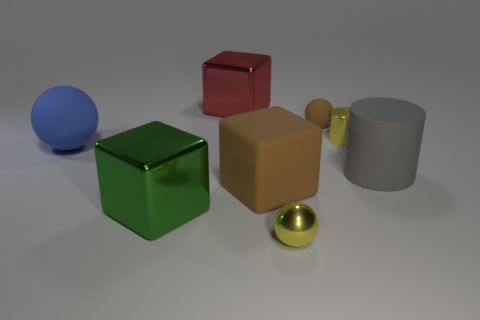The metallic sphere is what size?
Make the answer very short. Small. What number of matte things are the same size as the green block?
Make the answer very short. 3. Do the matte thing on the left side of the big green shiny thing and the metal cube that is in front of the small brown thing have the same size?
Ensure brevity in your answer.  Yes. The big object that is behind the blue matte sphere has what shape?
Ensure brevity in your answer.  Cube. What is the yellow object in front of the small thing that is to the right of the small rubber ball made of?
Make the answer very short. Metal. Is there a rubber thing that has the same color as the tiny matte sphere?
Your answer should be compact. Yes. There is a blue rubber object; is its size the same as the brown thing on the left side of the yellow metal sphere?
Make the answer very short. Yes. There is a small shiny thing behind the yellow object in front of the big blue rubber ball; what number of small rubber balls are to the left of it?
Make the answer very short. 1. How many red things are in front of the brown matte block?
Give a very brief answer. 0. There is a matte thing that is left of the big block that is behind the big matte ball; what color is it?
Your answer should be very brief. Blue. 